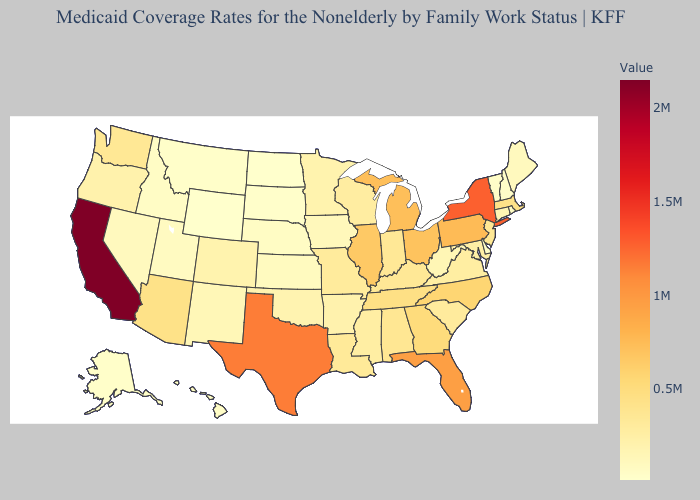Among the states that border Oklahoma , does Kansas have the lowest value?
Quick response, please. Yes. Does Indiana have a lower value than New York?
Answer briefly. Yes. Which states hav the highest value in the Northeast?
Concise answer only. New York. Does Kentucky have the highest value in the South?
Write a very short answer. No. Among the states that border Iowa , which have the lowest value?
Write a very short answer. South Dakota. Which states have the highest value in the USA?
Be succinct. California. 